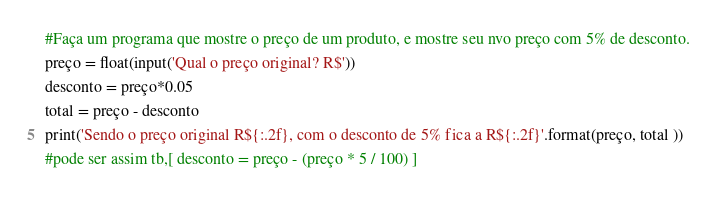<code> <loc_0><loc_0><loc_500><loc_500><_Python_>#Faça um programa que mostre o preço de um produto, e mostre seu nvo preço com 5% de desconto.
preço = float(input('Qual o preço original? R$'))
desconto = preço*0.05
total = preço - desconto
print('Sendo o preço original R${:.2f}, com o desconto de 5% fica a R${:.2f}'.format(preço, total ))
#pode ser assim tb,[ desconto = preço - (preço * 5 / 100) ]</code> 